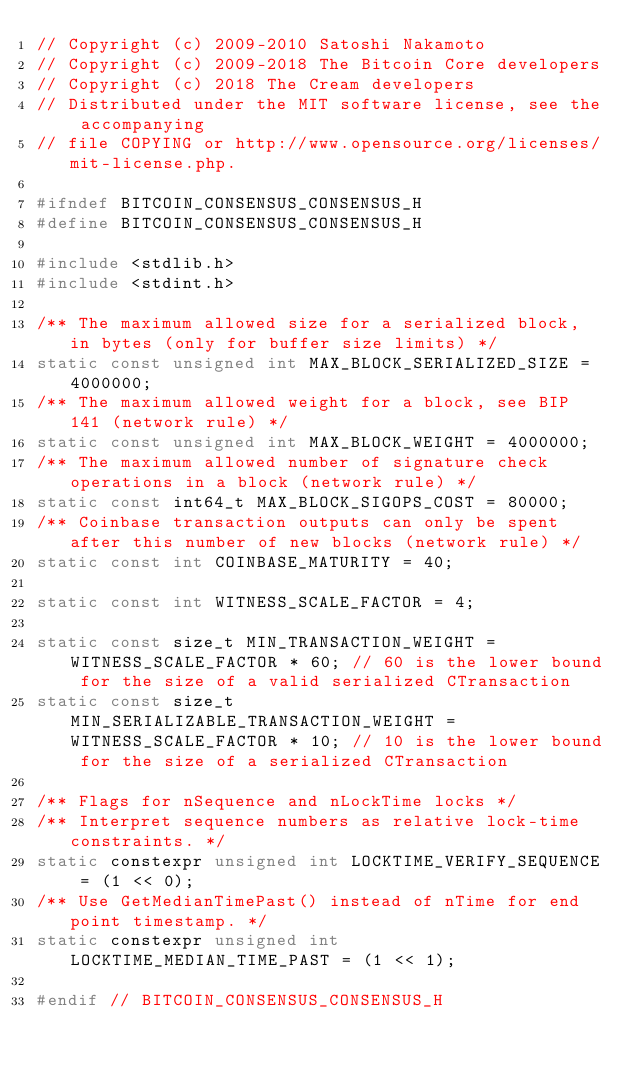Convert code to text. <code><loc_0><loc_0><loc_500><loc_500><_C_>// Copyright (c) 2009-2010 Satoshi Nakamoto
// Copyright (c) 2009-2018 The Bitcoin Core developers
// Copyright (c) 2018 The Cream developers
// Distributed under the MIT software license, see the accompanying
// file COPYING or http://www.opensource.org/licenses/mit-license.php.

#ifndef BITCOIN_CONSENSUS_CONSENSUS_H
#define BITCOIN_CONSENSUS_CONSENSUS_H

#include <stdlib.h>
#include <stdint.h>

/** The maximum allowed size for a serialized block, in bytes (only for buffer size limits) */
static const unsigned int MAX_BLOCK_SERIALIZED_SIZE = 4000000;
/** The maximum allowed weight for a block, see BIP 141 (network rule) */
static const unsigned int MAX_BLOCK_WEIGHT = 4000000;
/** The maximum allowed number of signature check operations in a block (network rule) */
static const int64_t MAX_BLOCK_SIGOPS_COST = 80000;
/** Coinbase transaction outputs can only be spent after this number of new blocks (network rule) */
static const int COINBASE_MATURITY = 40;

static const int WITNESS_SCALE_FACTOR = 4;

static const size_t MIN_TRANSACTION_WEIGHT = WITNESS_SCALE_FACTOR * 60; // 60 is the lower bound for the size of a valid serialized CTransaction
static const size_t MIN_SERIALIZABLE_TRANSACTION_WEIGHT = WITNESS_SCALE_FACTOR * 10; // 10 is the lower bound for the size of a serialized CTransaction

/** Flags for nSequence and nLockTime locks */
/** Interpret sequence numbers as relative lock-time constraints. */
static constexpr unsigned int LOCKTIME_VERIFY_SEQUENCE = (1 << 0);
/** Use GetMedianTimePast() instead of nTime for end point timestamp. */
static constexpr unsigned int LOCKTIME_MEDIAN_TIME_PAST = (1 << 1);

#endif // BITCOIN_CONSENSUS_CONSENSUS_H

</code> 